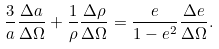Convert formula to latex. <formula><loc_0><loc_0><loc_500><loc_500>\frac { 3 } { a } \frac { \Delta a } { \Delta \Omega } + \frac { 1 } { \rho } \frac { \Delta \rho } { \Delta \Omega } = \frac { e } { 1 - e ^ { 2 } } \frac { \Delta e } { \Delta \Omega } .</formula> 